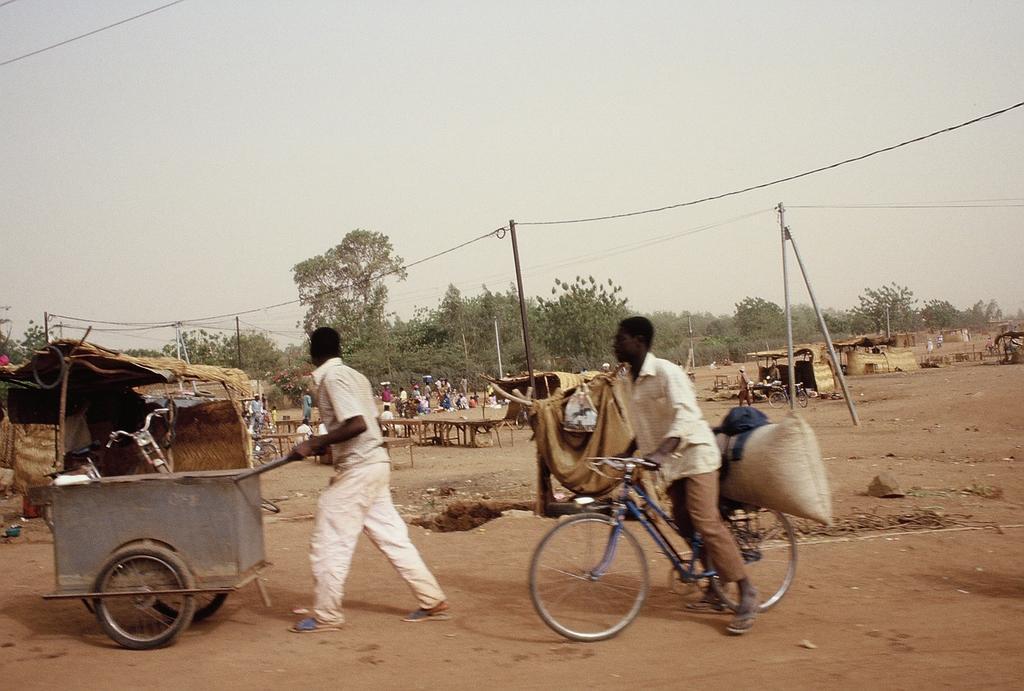Could you give a brief overview of what you see in this image? This picture describes about group of people few are seated on the chair and few are walking, a man is riding a bicycle, in the background we can see a hut, poles and couple of trees. 